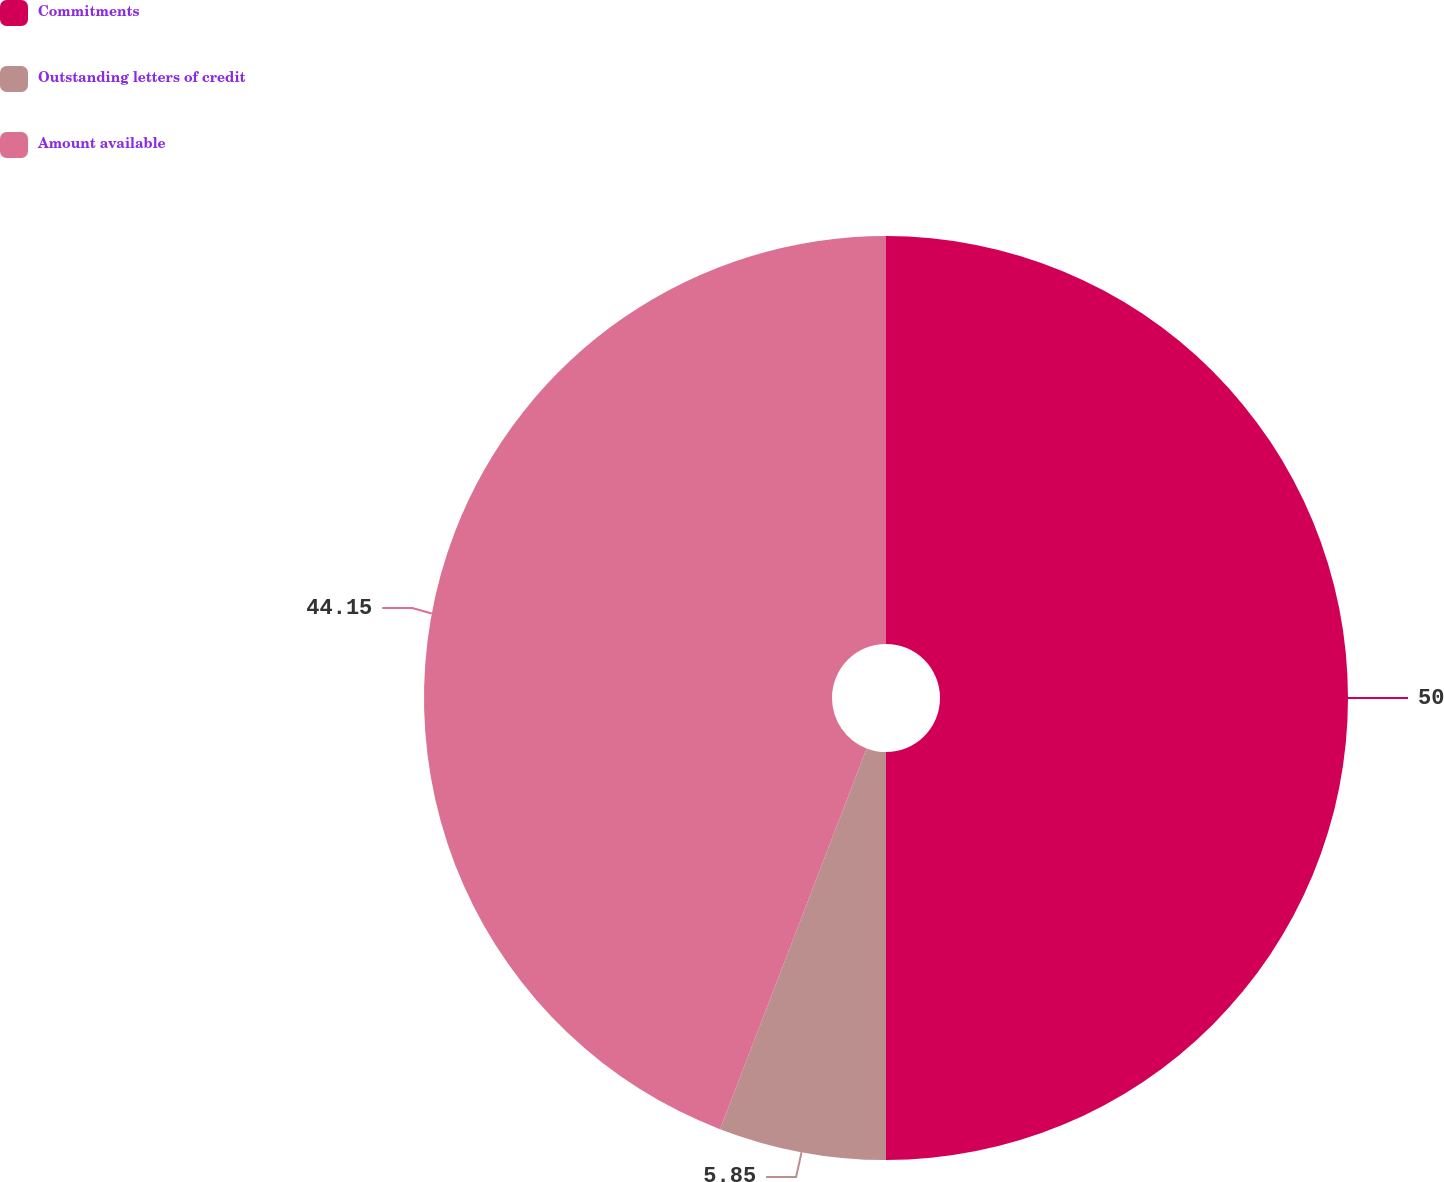Convert chart to OTSL. <chart><loc_0><loc_0><loc_500><loc_500><pie_chart><fcel>Commitments<fcel>Outstanding letters of credit<fcel>Amount available<nl><fcel>50.0%<fcel>5.85%<fcel>44.15%<nl></chart> 